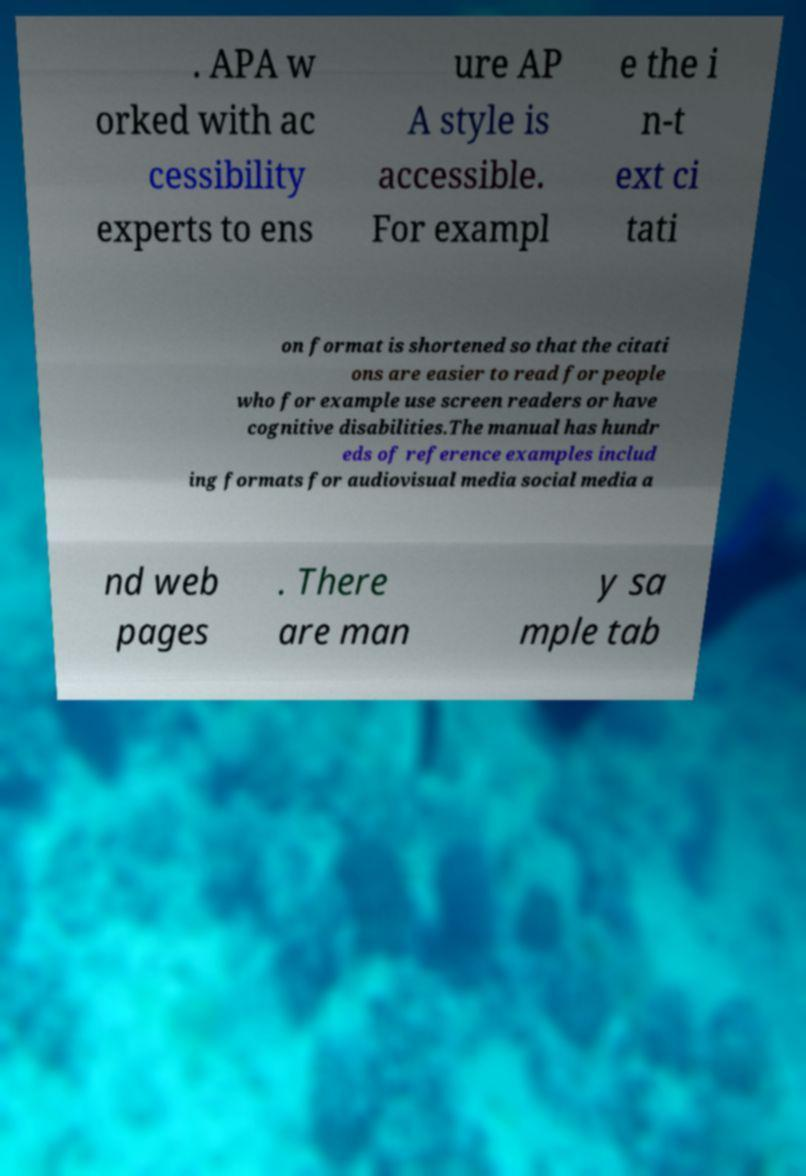I need the written content from this picture converted into text. Can you do that? . APA w orked with ac cessibility experts to ens ure AP A style is accessible. For exampl e the i n-t ext ci tati on format is shortened so that the citati ons are easier to read for people who for example use screen readers or have cognitive disabilities.The manual has hundr eds of reference examples includ ing formats for audiovisual media social media a nd web pages . There are man y sa mple tab 